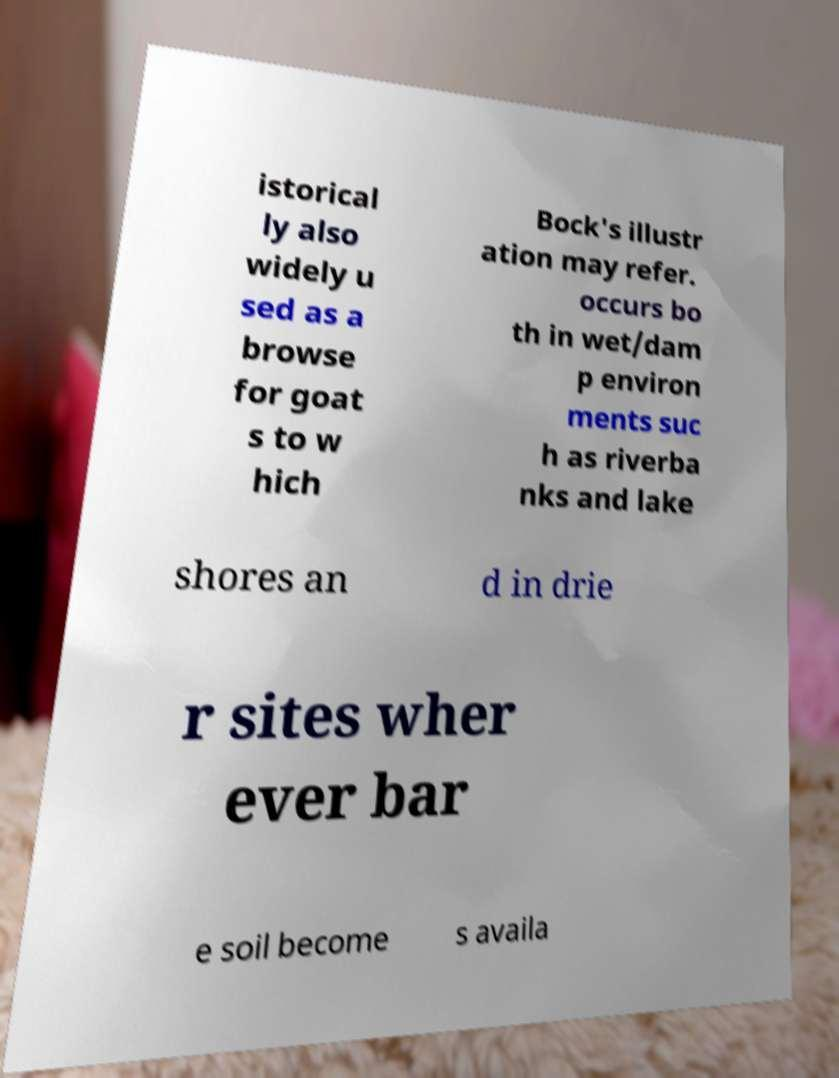Could you extract and type out the text from this image? istorical ly also widely u sed as a browse for goat s to w hich Bock's illustr ation may refer. occurs bo th in wet/dam p environ ments suc h as riverba nks and lake shores an d in drie r sites wher ever bar e soil become s availa 